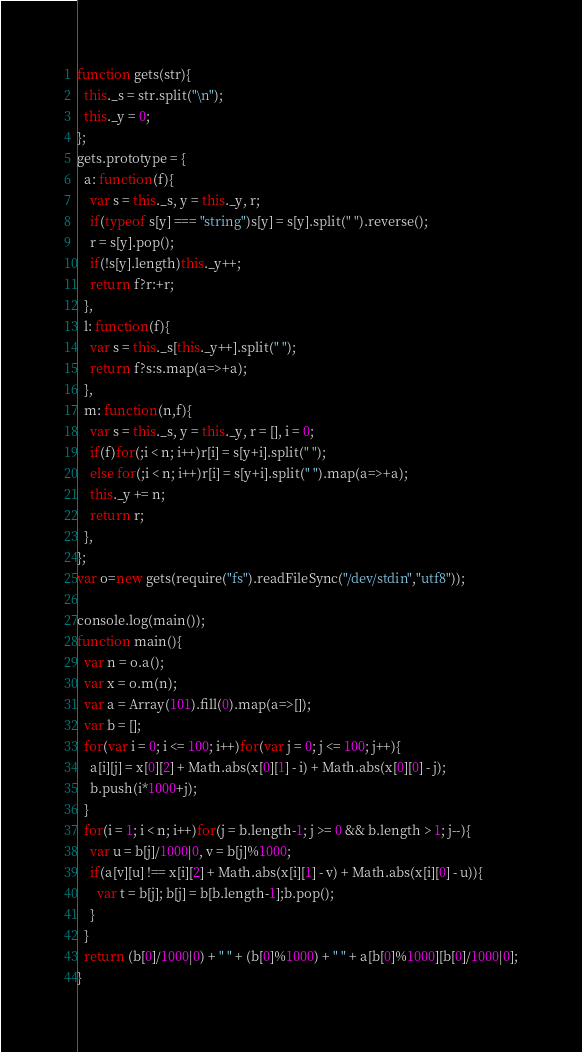Convert code to text. <code><loc_0><loc_0><loc_500><loc_500><_JavaScript_>function gets(str){
  this._s = str.split("\n");
  this._y = 0;
};
gets.prototype = {
  a: function(f){
    var s = this._s, y = this._y, r;
    if(typeof s[y] === "string")s[y] = s[y].split(" ").reverse();
    r = s[y].pop();
    if(!s[y].length)this._y++;
    return f?r:+r;
  },
  l: function(f){
    var s = this._s[this._y++].split(" ");
    return f?s:s.map(a=>+a);
  },
  m: function(n,f){
    var s = this._s, y = this._y, r = [], i = 0;
    if(f)for(;i < n; i++)r[i] = s[y+i].split(" ");
    else for(;i < n; i++)r[i] = s[y+i].split(" ").map(a=>+a);
    this._y += n;
    return r;
  },
};
var o=new gets(require("fs").readFileSync("/dev/stdin","utf8"));

console.log(main());
function main(){
  var n = o.a();
  var x = o.m(n);
  var a = Array(101).fill(0).map(a=>[]);
  var b = [];
  for(var i = 0; i <= 100; i++)for(var j = 0; j <= 100; j++){
    a[i][j] = x[0][2] + Math.abs(x[0][1] - i) + Math.abs(x[0][0] - j);
    b.push(i*1000+j);
  }
  for(i = 1; i < n; i++)for(j = b.length-1; j >= 0 && b.length > 1; j--){
    var u = b[j]/1000|0, v = b[j]%1000;
    if(a[v][u] !== x[i][2] + Math.abs(x[i][1] - v) + Math.abs(x[i][0] - u)){
      var t = b[j]; b[j] = b[b.length-1];b.pop();
    }
  }
  return (b[0]/1000|0) + " " + (b[0]%1000) + " " + a[b[0]%1000][b[0]/1000|0];
}</code> 